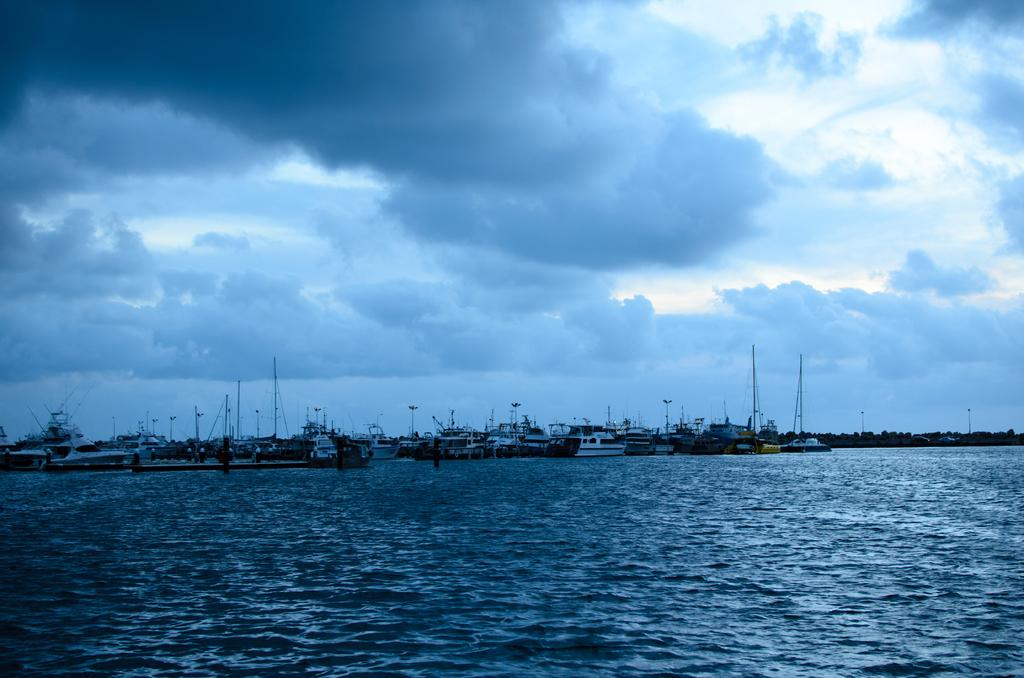What can be seen in the sky in the image? There are clouds in the sky in the image. What is on the water in the image? There are boats on the water in the image. What type of vegetation is visible in the background? There are trees visible in the background in the image. What type of wrench is being used to connect the apples in the image? There are no wrenches or apples present in the image; it features clouds, boats, and trees. 